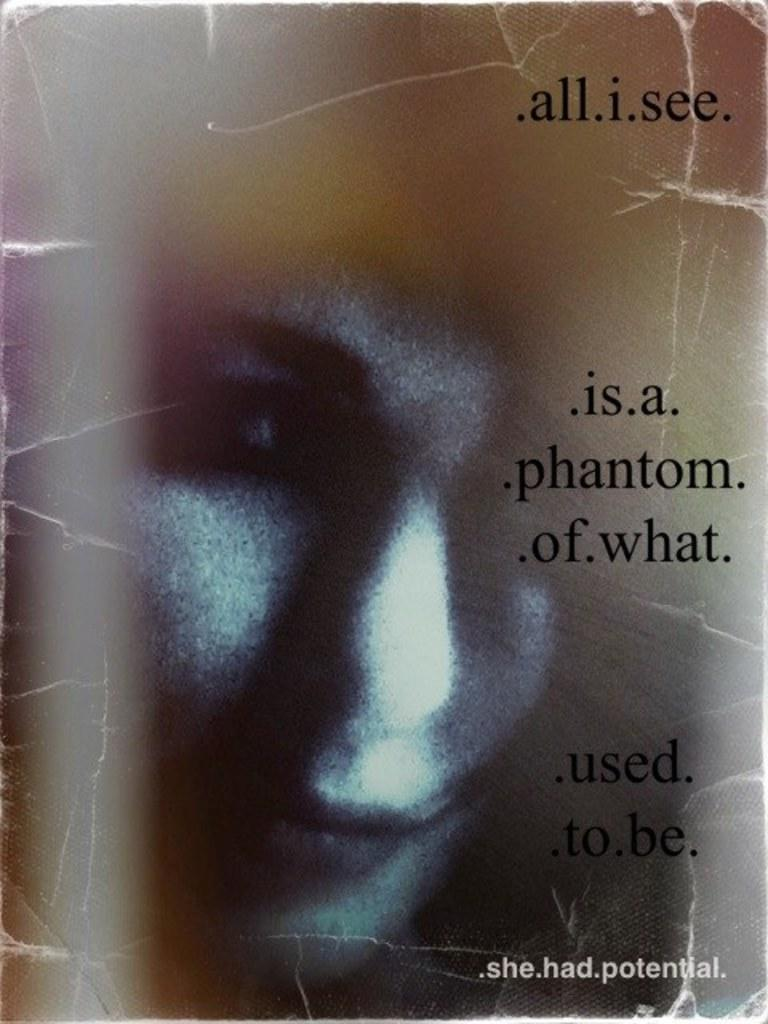What is the main subject of the poster in the image? The poster features a woman. What else can be seen on the poster besides the woman? There is text on the poster. How many men are depicted on the poster? There are no men depicted on the poster; it features a woman. What language is used in the text on the poster? The provided facts do not mention the language used in the text on the poster, so we cannot determine that information from the image. 